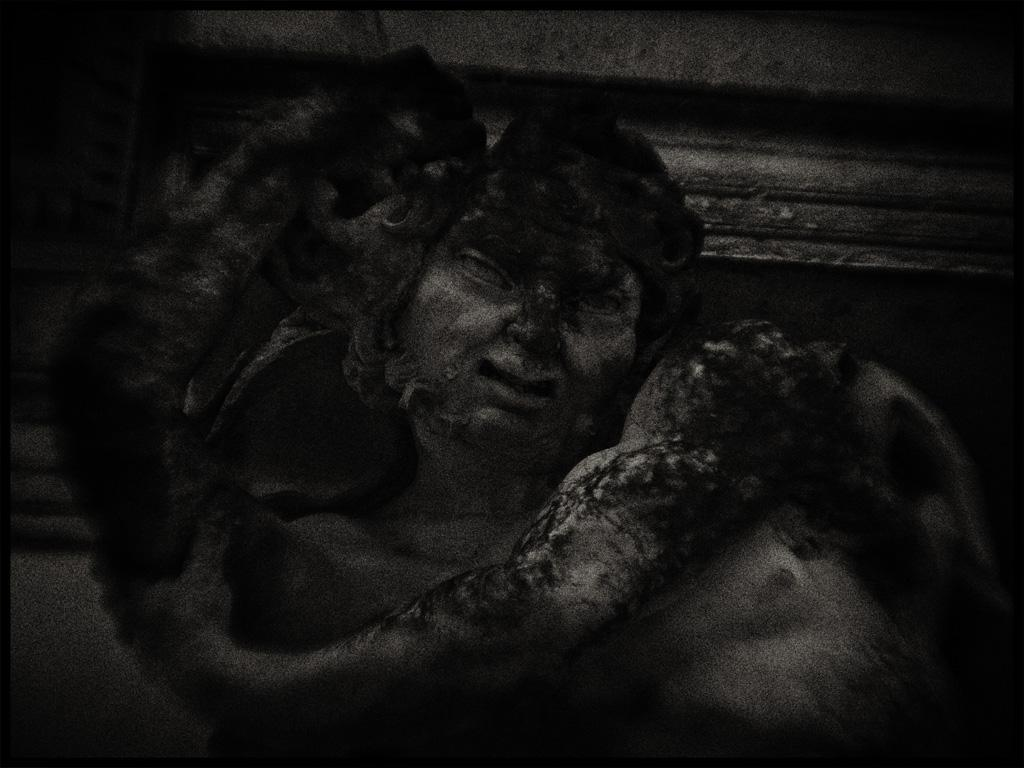What is the color scheme of the image? The image is black and white. What can be seen in the image? There is a depiction of a person in the image. What type of shoes is the person wearing in the image? There is no information about shoes in the image, as it is black and white and only depicts a person. 